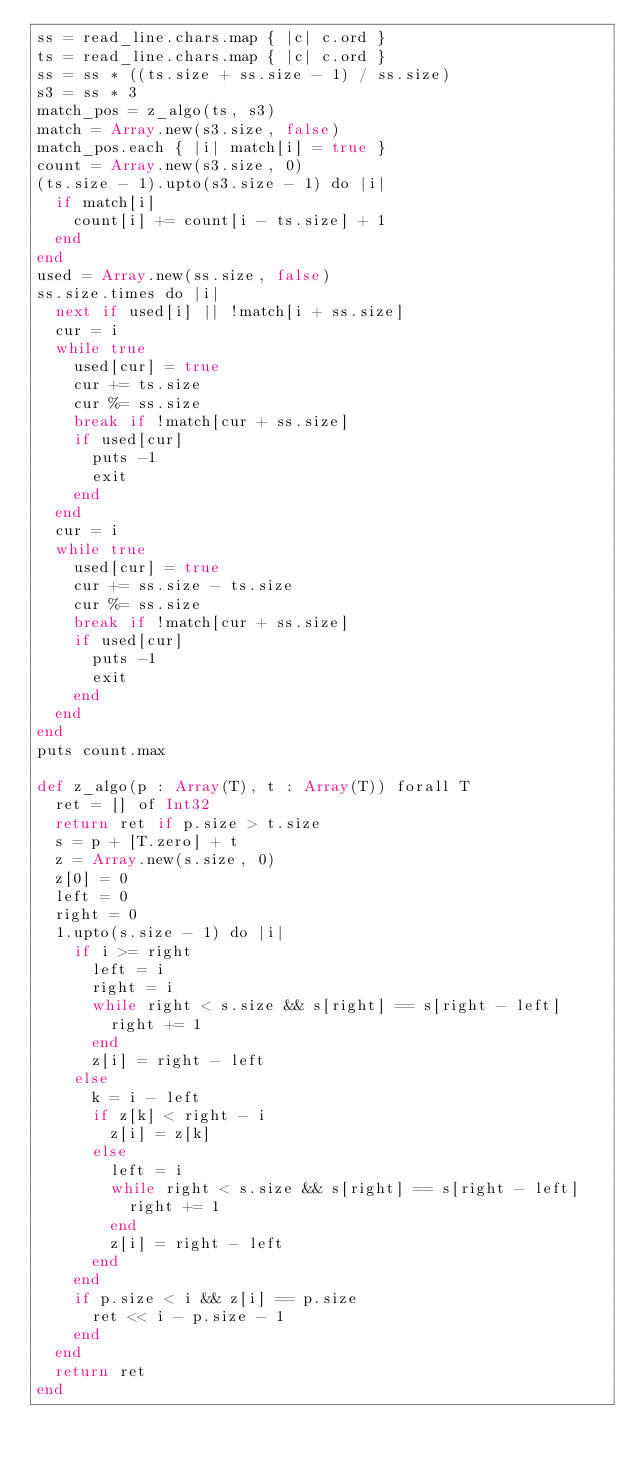Convert code to text. <code><loc_0><loc_0><loc_500><loc_500><_Crystal_>ss = read_line.chars.map { |c| c.ord }
ts = read_line.chars.map { |c| c.ord }
ss = ss * ((ts.size + ss.size - 1) / ss.size)
s3 = ss * 3
match_pos = z_algo(ts, s3)
match = Array.new(s3.size, false)
match_pos.each { |i| match[i] = true }
count = Array.new(s3.size, 0)
(ts.size - 1).upto(s3.size - 1) do |i|
  if match[i]
    count[i] += count[i - ts.size] + 1
  end
end
used = Array.new(ss.size, false)
ss.size.times do |i|
  next if used[i] || !match[i + ss.size]
  cur = i
  while true
    used[cur] = true
    cur += ts.size
    cur %= ss.size
    break if !match[cur + ss.size]
    if used[cur]
      puts -1
      exit
    end
  end
  cur = i
  while true
    used[cur] = true
    cur += ss.size - ts.size
    cur %= ss.size
    break if !match[cur + ss.size]
    if used[cur]
      puts -1
      exit
    end
  end
end
puts count.max

def z_algo(p : Array(T), t : Array(T)) forall T
  ret = [] of Int32
  return ret if p.size > t.size
  s = p + [T.zero] + t
  z = Array.new(s.size, 0)
  z[0] = 0
  left = 0
  right = 0
  1.upto(s.size - 1) do |i|
    if i >= right
      left = i
      right = i
      while right < s.size && s[right] == s[right - left]
        right += 1
      end
      z[i] = right - left
    else
      k = i - left
      if z[k] < right - i
        z[i] = z[k]
      else
        left = i
        while right < s.size && s[right] == s[right - left]
          right += 1
        end
        z[i] = right - left
      end
    end
    if p.size < i && z[i] == p.size
      ret << i - p.size - 1
    end
  end
  return ret
end
</code> 